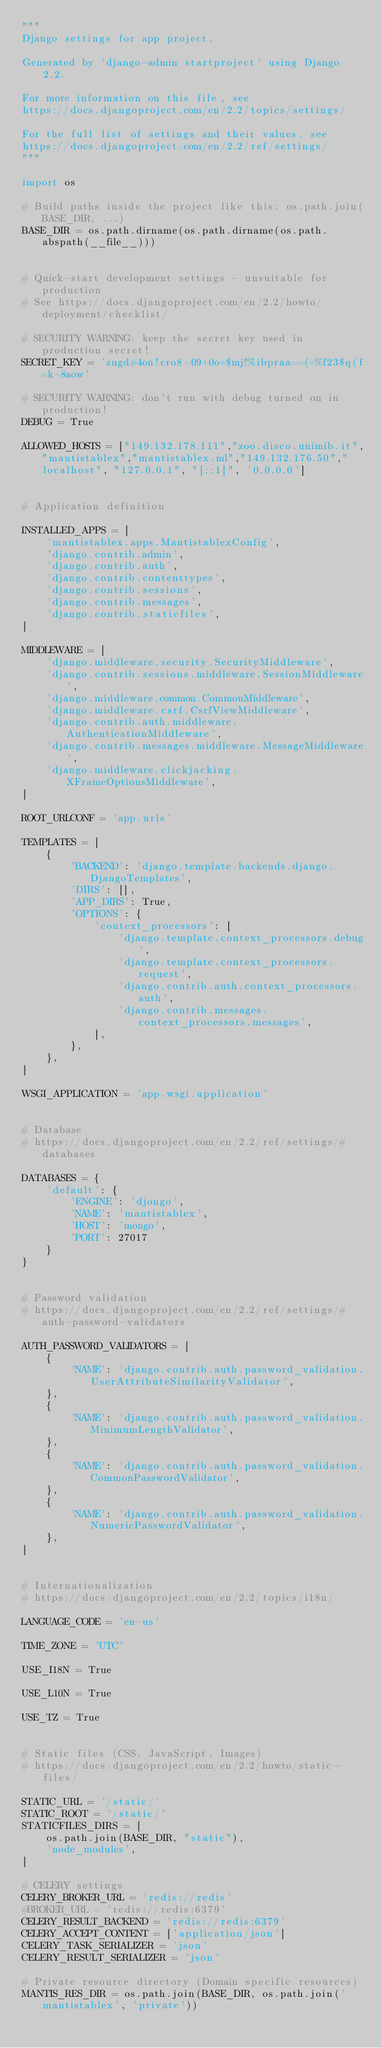<code> <loc_0><loc_0><loc_500><loc_500><_Python_>"""
Django settings for app project.

Generated by 'django-admin startproject' using Django 2.2.

For more information on this file, see
https://docs.djangoproject.com/en/2.2/topics/settings/

For the full list of settings and their values, see
https://docs.djangoproject.com/en/2.2/ref/settings/
"""

import os

# Build paths inside the project like this: os.path.join(BASE_DIR, ...)
BASE_DIR = os.path.dirname(os.path.dirname(os.path.abspath(__file__)))


# Quick-start development settings - unsuitable for production
# See https://docs.djangoproject.com/en/2.2/howto/deployment/checklist/

# SECURITY WARNING: keep the secret key used in production secret!
SECRET_KEY = 'zugd#4on!cro8-09+0o+$mj!%ibpraa==(=%f23$q(f=k-8aow'

# SECURITY WARNING: don't run with debug turned on in production!
DEBUG = True

ALLOWED_HOSTS = ["149.132.178.111","zoo.disco.unimib.it","mantistablex","mantistablex.ml","149.132.176.50","localhost", "127.0.0.1", "[::1]", '0.0.0.0']


# Application definition

INSTALLED_APPS = [
    'mantistablex.apps.MantistablexConfig',
    'django.contrib.admin',
    'django.contrib.auth',
    'django.contrib.contenttypes',
    'django.contrib.sessions',
    'django.contrib.messages',
    'django.contrib.staticfiles',
]

MIDDLEWARE = [
    'django.middleware.security.SecurityMiddleware',
    'django.contrib.sessions.middleware.SessionMiddleware',
    'django.middleware.common.CommonMiddleware',
    'django.middleware.csrf.CsrfViewMiddleware',
    'django.contrib.auth.middleware.AuthenticationMiddleware',
    'django.contrib.messages.middleware.MessageMiddleware',
    'django.middleware.clickjacking.XFrameOptionsMiddleware',
]

ROOT_URLCONF = 'app.urls'

TEMPLATES = [
    {
        'BACKEND': 'django.template.backends.django.DjangoTemplates',
        'DIRS': [],
        'APP_DIRS': True,
        'OPTIONS': {
            'context_processors': [
                'django.template.context_processors.debug',
                'django.template.context_processors.request',
                'django.contrib.auth.context_processors.auth',
                'django.contrib.messages.context_processors.messages',
            ],
        },
    },
]

WSGI_APPLICATION = 'app.wsgi.application'


# Database
# https://docs.djangoproject.com/en/2.2/ref/settings/#databases

DATABASES = {
    'default': {
        'ENGINE': 'djongo',
        'NAME': 'mantistablex',
        'HOST': 'mongo',
        'PORT': 27017
    }
}


# Password validation
# https://docs.djangoproject.com/en/2.2/ref/settings/#auth-password-validators

AUTH_PASSWORD_VALIDATORS = [
    {
        'NAME': 'django.contrib.auth.password_validation.UserAttributeSimilarityValidator',
    },
    {
        'NAME': 'django.contrib.auth.password_validation.MinimumLengthValidator',
    },
    {
        'NAME': 'django.contrib.auth.password_validation.CommonPasswordValidator',
    },
    {
        'NAME': 'django.contrib.auth.password_validation.NumericPasswordValidator',
    },
]


# Internationalization
# https://docs.djangoproject.com/en/2.2/topics/i18n/

LANGUAGE_CODE = 'en-us'

TIME_ZONE = 'UTC'

USE_I18N = True

USE_L10N = True

USE_TZ = True


# Static files (CSS, JavaScript, Images)
# https://docs.djangoproject.com/en/2.2/howto/static-files/

STATIC_URL = '/static/'
STATIC_ROOT = '/static/'
STATICFILES_DIRS = [
    os.path.join(BASE_DIR, "static"),
    'node_modules',
]

# CELERY settings
CELERY_BROKER_URL = 'redis://redis'
#BROKER_URL = 'redis://redis:6379'
CELERY_RESULT_BACKEND = 'redis://redis:6379'
CELERY_ACCEPT_CONTENT = ['application/json']
CELERY_TASK_SERIALIZER = 'json'
CELERY_RESULT_SERIALIZER = 'json'

# Private resource directory (Domain specific resources)
MANTIS_RES_DIR = os.path.join(BASE_DIR, os.path.join('mantistablex', 'private'))
</code> 